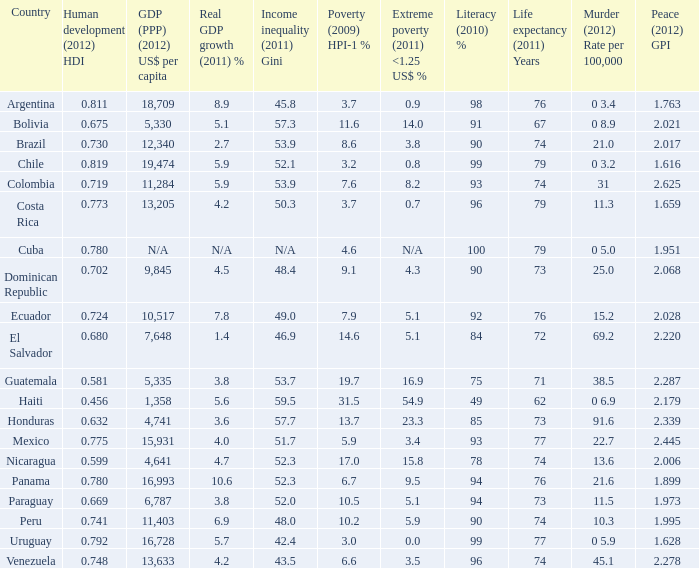616 as the serenity (2012) gpi? 0 3.2. 